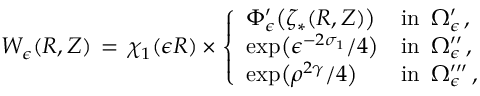Convert formula to latex. <formula><loc_0><loc_0><loc_500><loc_500>W _ { \epsilon } ( R , Z ) \, = \, \chi _ { 1 } ( \epsilon R ) \times \left \{ \begin{array} { l l } { \Phi _ { \epsilon } ^ { \prime } \left ( \zeta _ { * } ( R , Z ) \right ) } & { i n \, \Omega _ { \epsilon } ^ { \prime } \, , } \\ { \exp \left ( \epsilon ^ { - 2 \sigma _ { 1 } } / 4 \right ) } & { i n \, \Omega _ { \epsilon } ^ { \prime \prime } \, , } \\ { \exp \left ( \rho ^ { 2 \gamma } / 4 \right ) } & { i n \, \Omega _ { \epsilon } ^ { \prime \prime \prime } \, , } \end{array}</formula> 